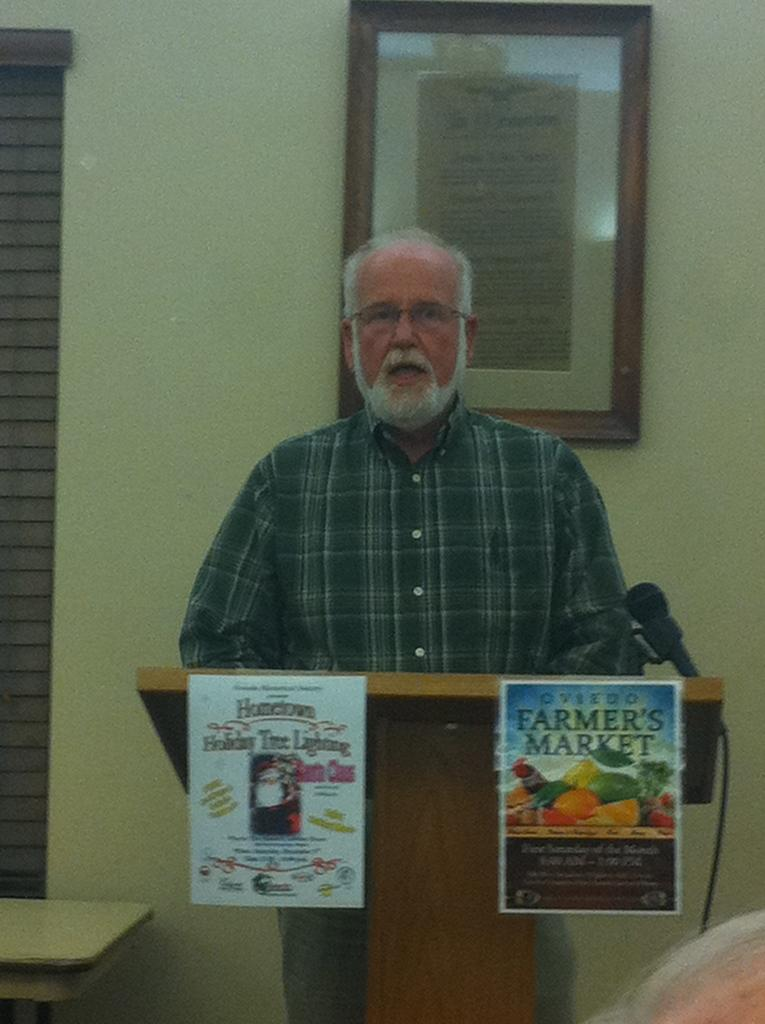What is the person in the image doing? The person is standing near a podium. What can be seen in the background of the image? There is a wall with a photo frame in the background. Are there any other items or objects near the podium? Yes, there are posters near the podium. What grade did the person receive for their presentation in the image? There is no indication of a presentation or grade in the image. How does the fan help the person at the podium in the image? There is no fan present in the image. 